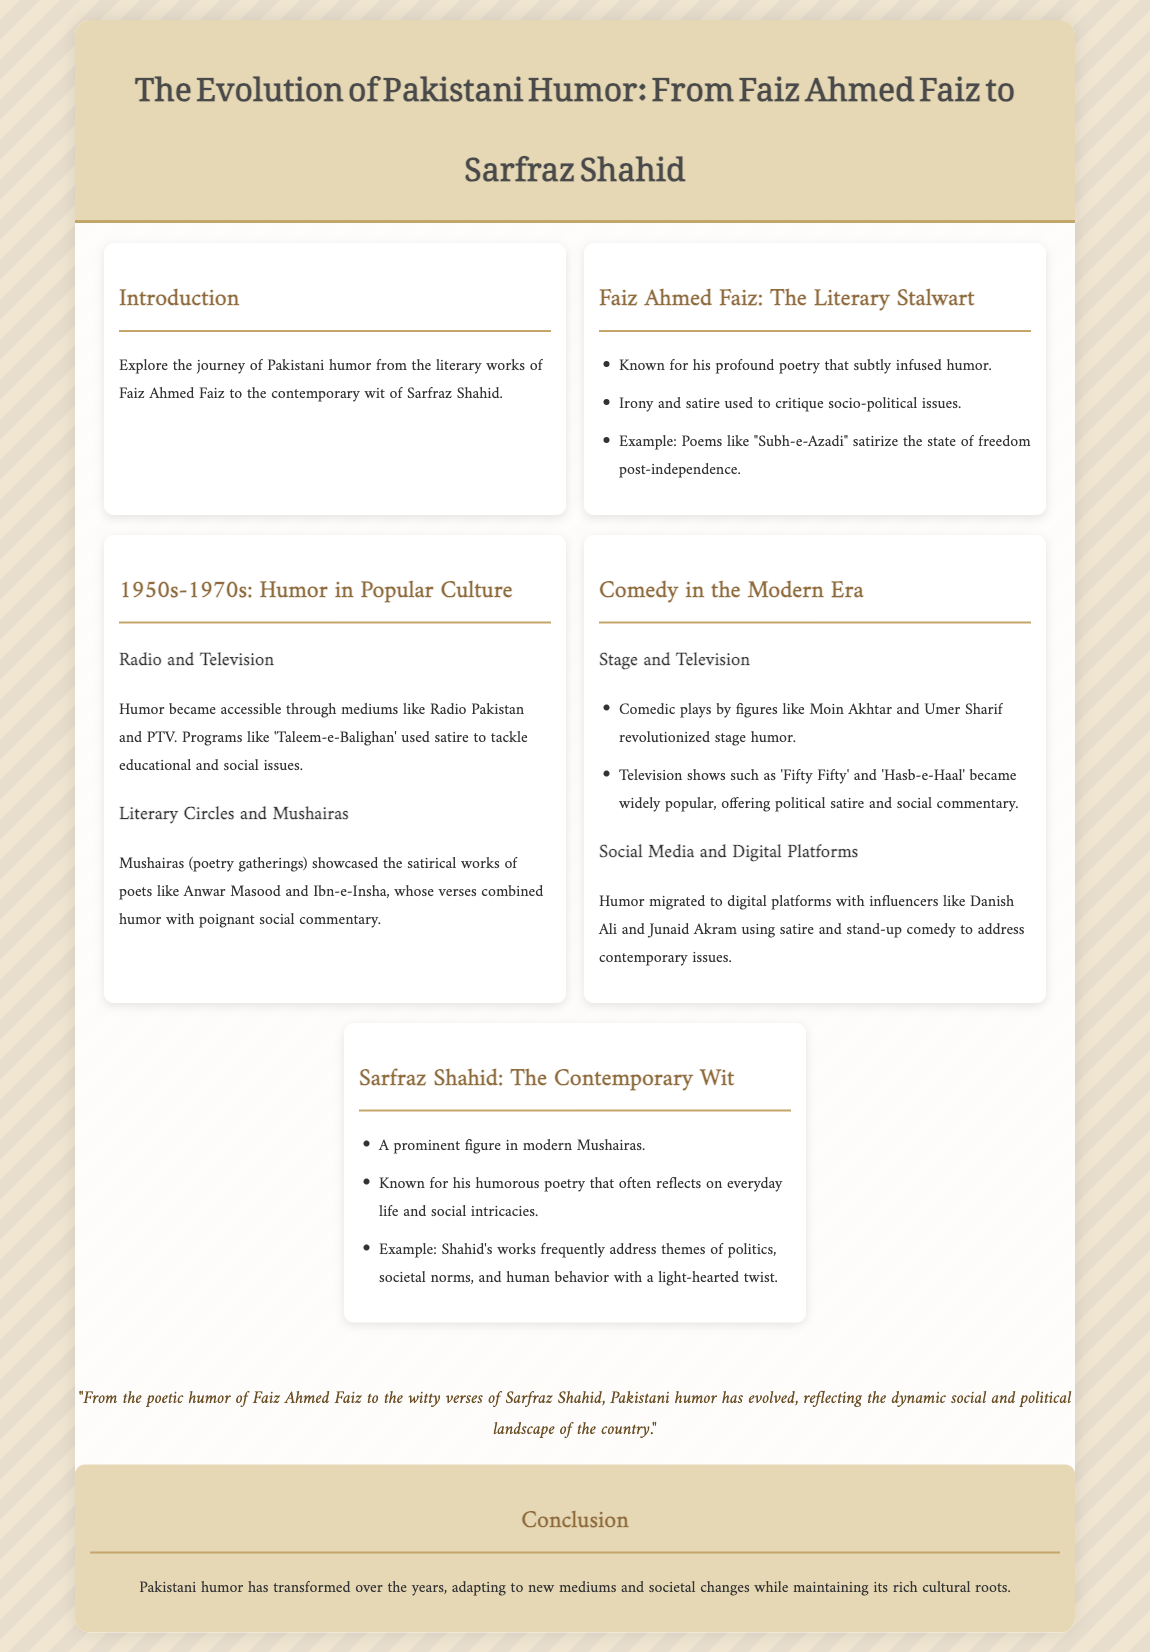What is the title of the presentation? The title is prominently displayed at the top of the document, stating the focus of the presentation.
Answer: The Evolution of Pakistani Humor: From Faiz Ahmed Faiz to Sarfraz Shahid Who is the literary stalwart mentioned in the document? This question seeks to identify the key figure in the realm of literature and humor as introduced in the presentation.
Answer: Faiz Ahmed Faiz What medium became popular for humor in the 1950s-1970s? The document discusses various mediums that helped spread humor during this time period, highlighting one key medium.
Answer: Radio and Television Which two figures revolutionized stage humor mentioned in the modern era? This question requires the names of significant contributors to stage humor based on the information presented.
Answer: Moin Akhtar and Umer Sharif What type of poetry is Sarfraz Shahid known for? This question focuses on the style or content of poetry associated with a contemporary humorist.
Answer: Humorous poetry Which social media influencers are mentioned as addressing contemporary issues? The document lists individuals who have transitioned humor into the digital age, focusing on social commentary.
Answer: Danish Ali and Junaid Akram What is the main theme discussed in Faiz Ahmed Faiz's poems like "Subh-e-Azadi"? This question seeks to identify the central critique or subject matter of Faiz's poetry highlighted in the presentation.
Answer: Socio-political issues What is highlighted as a significant feature of Mushairas in the 1950s-1970s? This question aims to identify the characteristics or contributions of poetry gatherings during this time.
Answer: Satirical works What has Pakistani humor maintained through its transformation over the years? This question looks for a fundamental aspect that has persisted despite changes in humor styles and mediums.
Answer: Cultural roots 